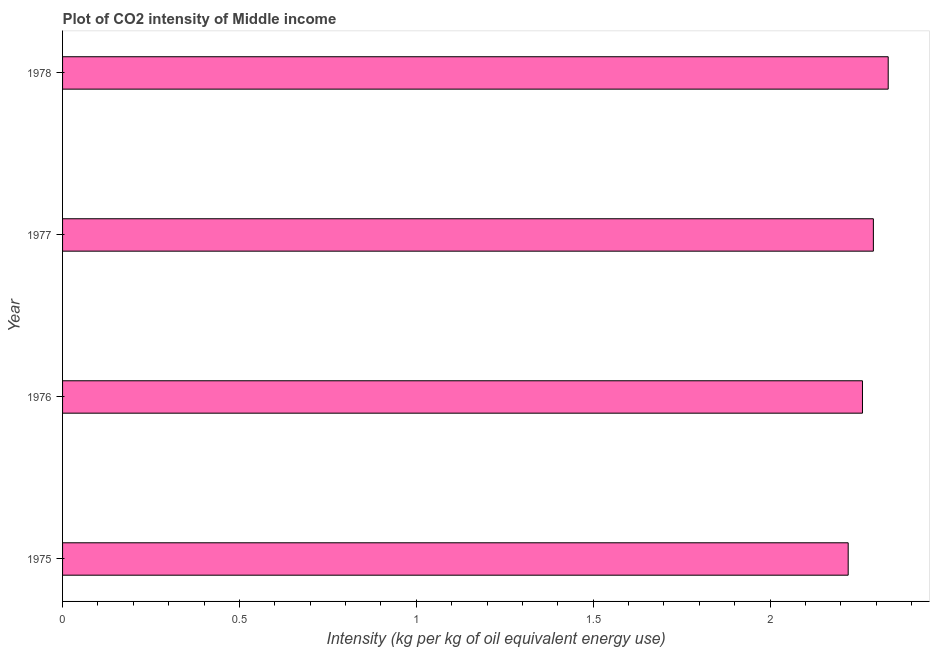What is the title of the graph?
Your answer should be compact. Plot of CO2 intensity of Middle income. What is the label or title of the X-axis?
Provide a succinct answer. Intensity (kg per kg of oil equivalent energy use). What is the co2 intensity in 1977?
Provide a succinct answer. 2.29. Across all years, what is the maximum co2 intensity?
Offer a terse response. 2.33. Across all years, what is the minimum co2 intensity?
Give a very brief answer. 2.22. In which year was the co2 intensity maximum?
Keep it short and to the point. 1978. In which year was the co2 intensity minimum?
Keep it short and to the point. 1975. What is the sum of the co2 intensity?
Provide a short and direct response. 9.11. What is the difference between the co2 intensity in 1976 and 1978?
Give a very brief answer. -0.07. What is the average co2 intensity per year?
Keep it short and to the point. 2.28. What is the median co2 intensity?
Give a very brief answer. 2.28. In how many years, is the co2 intensity greater than 1.2 kg?
Ensure brevity in your answer.  4. What is the ratio of the co2 intensity in 1975 to that in 1978?
Make the answer very short. 0.95. What is the difference between the highest and the second highest co2 intensity?
Keep it short and to the point. 0.04. What is the difference between the highest and the lowest co2 intensity?
Your answer should be very brief. 0.11. How many years are there in the graph?
Offer a very short reply. 4. What is the Intensity (kg per kg of oil equivalent energy use) of 1975?
Provide a succinct answer. 2.22. What is the Intensity (kg per kg of oil equivalent energy use) of 1976?
Your response must be concise. 2.26. What is the Intensity (kg per kg of oil equivalent energy use) of 1977?
Your answer should be very brief. 2.29. What is the Intensity (kg per kg of oil equivalent energy use) in 1978?
Your response must be concise. 2.33. What is the difference between the Intensity (kg per kg of oil equivalent energy use) in 1975 and 1976?
Ensure brevity in your answer.  -0.04. What is the difference between the Intensity (kg per kg of oil equivalent energy use) in 1975 and 1977?
Make the answer very short. -0.07. What is the difference between the Intensity (kg per kg of oil equivalent energy use) in 1975 and 1978?
Your answer should be compact. -0.11. What is the difference between the Intensity (kg per kg of oil equivalent energy use) in 1976 and 1977?
Offer a terse response. -0.03. What is the difference between the Intensity (kg per kg of oil equivalent energy use) in 1976 and 1978?
Ensure brevity in your answer.  -0.07. What is the difference between the Intensity (kg per kg of oil equivalent energy use) in 1977 and 1978?
Keep it short and to the point. -0.04. What is the ratio of the Intensity (kg per kg of oil equivalent energy use) in 1975 to that in 1976?
Offer a very short reply. 0.98. What is the ratio of the Intensity (kg per kg of oil equivalent energy use) in 1977 to that in 1978?
Give a very brief answer. 0.98. 